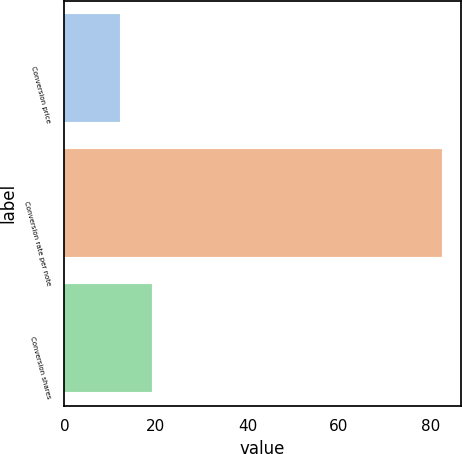Convert chart. <chart><loc_0><loc_0><loc_500><loc_500><bar_chart><fcel>Conversion price<fcel>Conversion rate per note<fcel>Conversion shares<nl><fcel>12.13<fcel>82.46<fcel>19.16<nl></chart> 